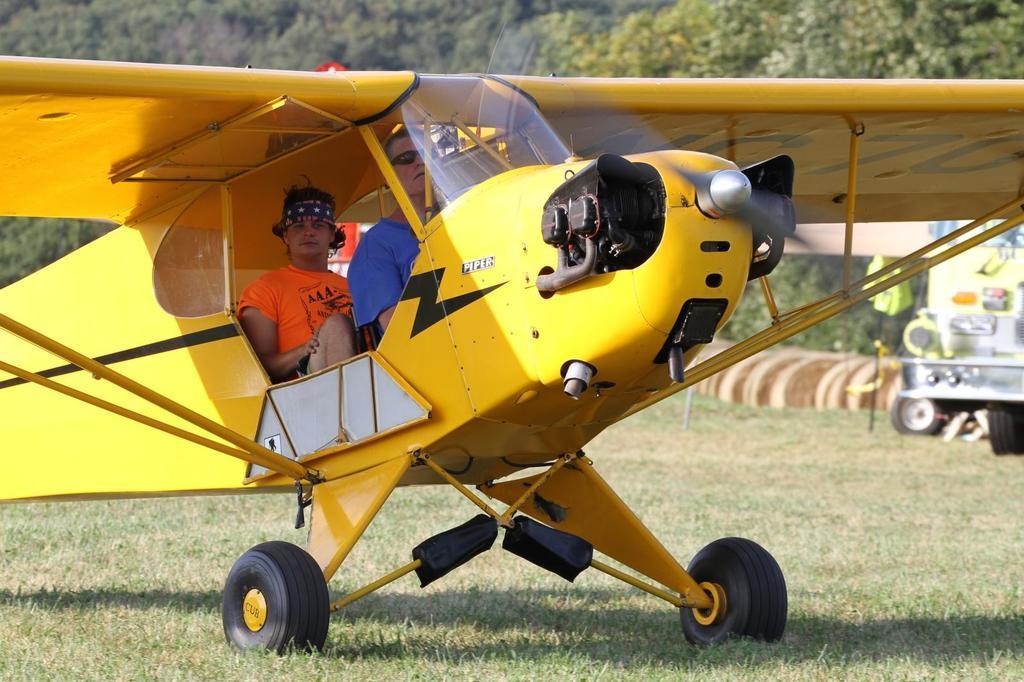Describe this image in one or two sentences. In this picture we can see two people sitting inside an aircraft. Some grass is visible on the ground. We can see a vehicle on the right side. Some trees are visible in the background. 